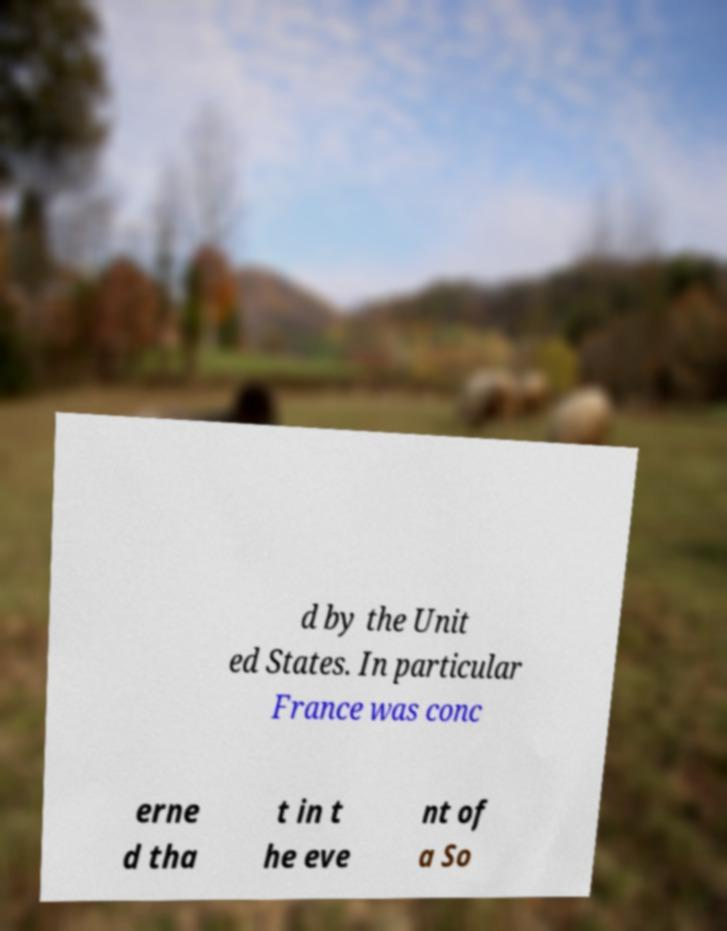There's text embedded in this image that I need extracted. Can you transcribe it verbatim? d by the Unit ed States. In particular France was conc erne d tha t in t he eve nt of a So 